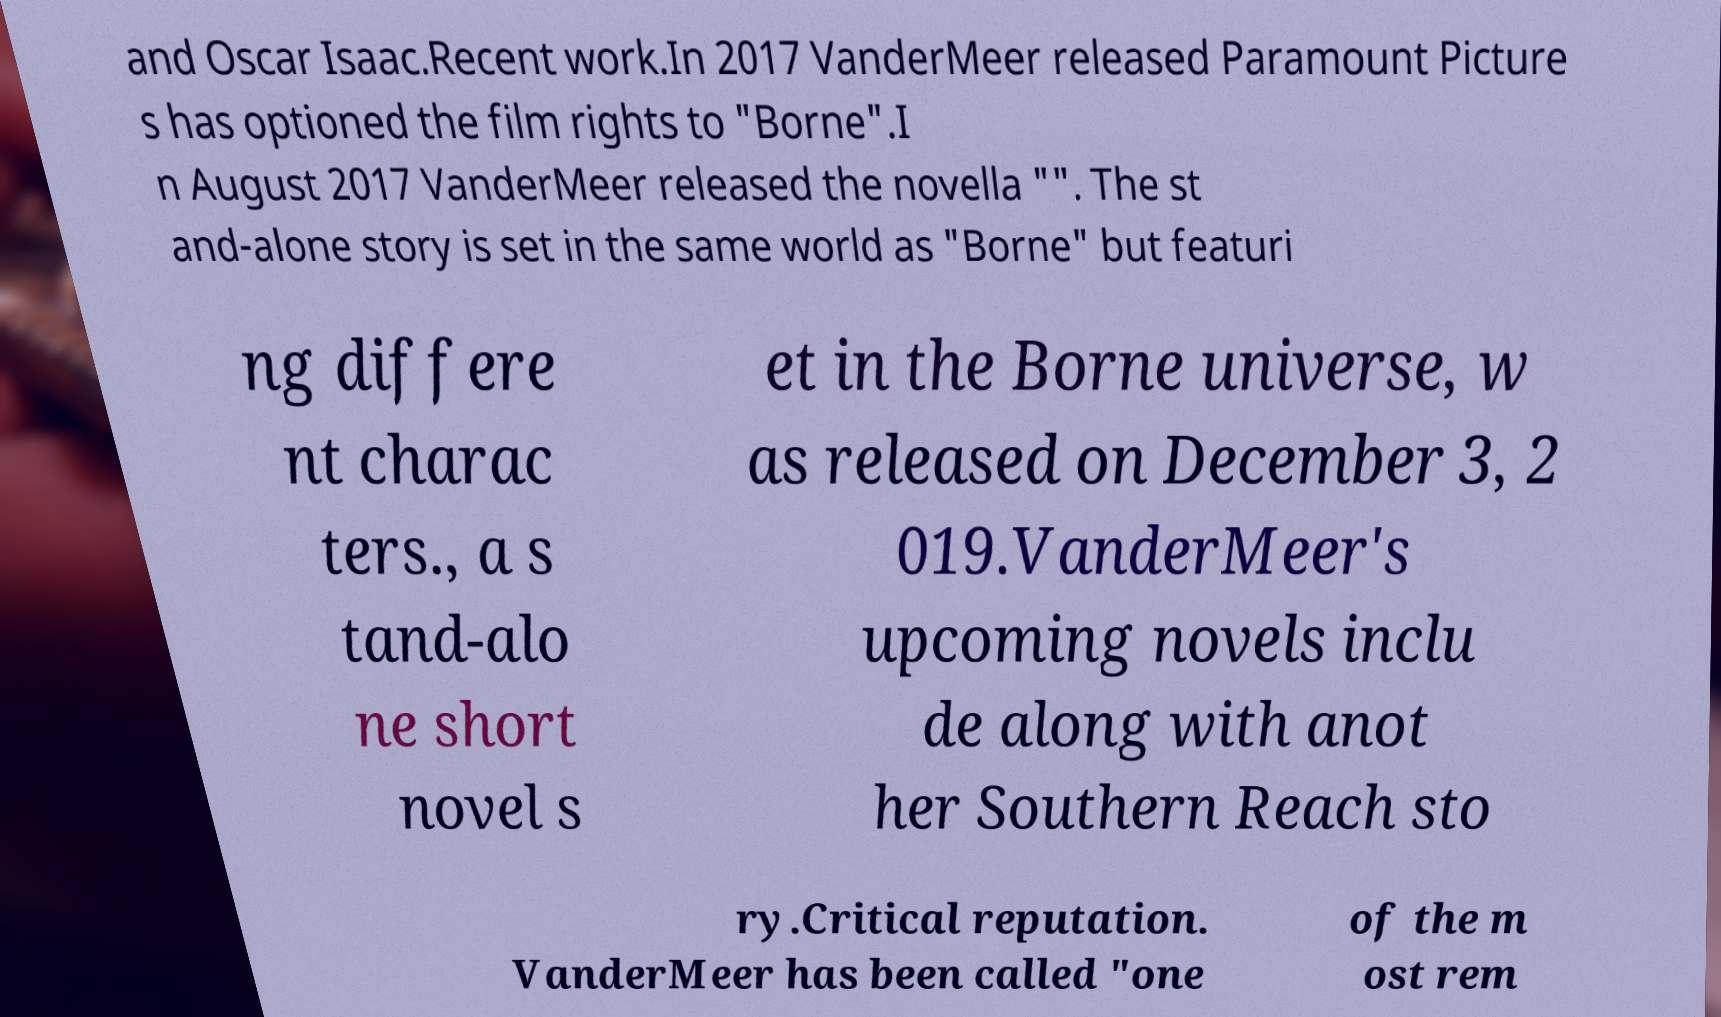Can you read and provide the text displayed in the image?This photo seems to have some interesting text. Can you extract and type it out for me? and Oscar Isaac.Recent work.In 2017 VanderMeer released Paramount Picture s has optioned the film rights to "Borne".I n August 2017 VanderMeer released the novella "". The st and-alone story is set in the same world as "Borne" but featuri ng differe nt charac ters., a s tand-alo ne short novel s et in the Borne universe, w as released on December 3, 2 019.VanderMeer's upcoming novels inclu de along with anot her Southern Reach sto ry.Critical reputation. VanderMeer has been called "one of the m ost rem 